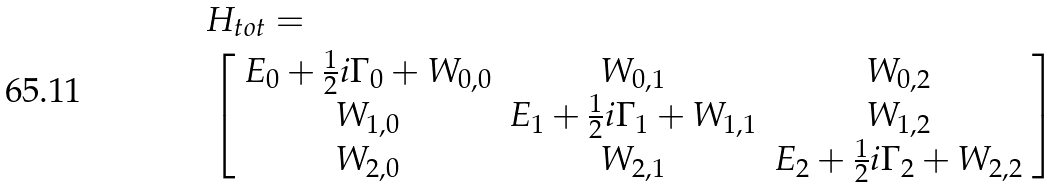<formula> <loc_0><loc_0><loc_500><loc_500>& H _ { t o t } = \\ & \left [ \begin{array} { c c c } E _ { 0 } + \frac { 1 } { 2 } i \Gamma _ { 0 } + W _ { 0 , 0 } & W _ { 0 , 1 } & W _ { 0 , 2 } \\ W _ { 1 , 0 } & E _ { 1 } + \frac { 1 } { 2 } i \Gamma _ { 1 } + W _ { 1 , 1 } & W _ { 1 , 2 } \\ W _ { 2 , 0 } & W _ { 2 , 1 } & E _ { 2 } + \frac { 1 } { 2 } i \Gamma _ { 2 } + W _ { 2 , 2 } \\ \end{array} \right ] \</formula> 